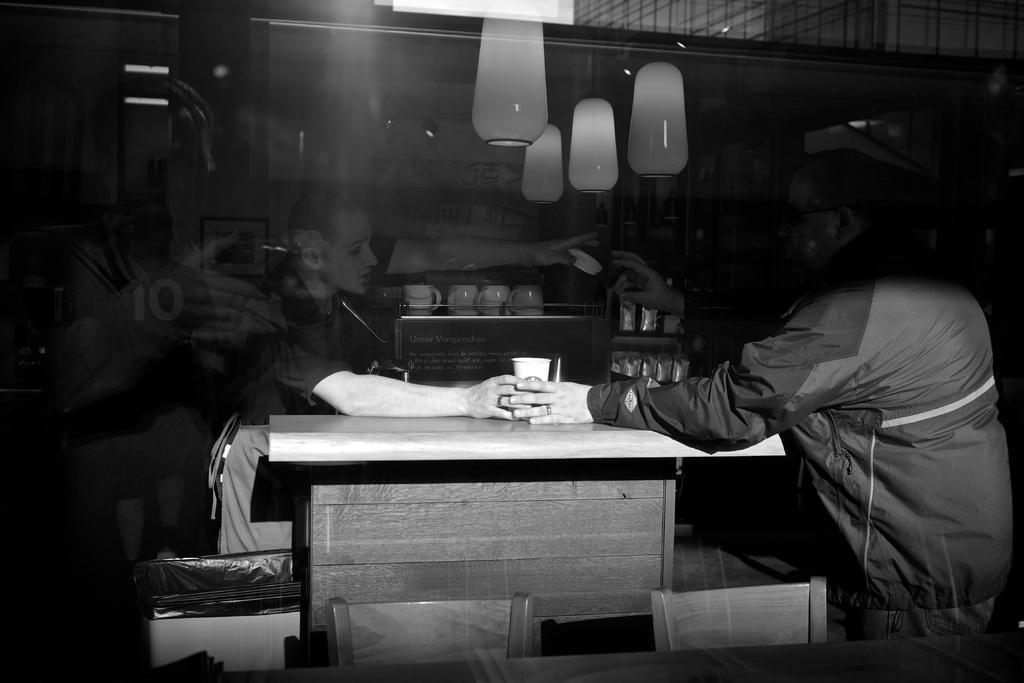How would you summarize this image in a sentence or two? This image is black and white image. There are lights on the top ,there is a table in the middle and two persons are near that table. One is on the right side and other one is on the left side. Both of them are holding a cup. Behind them there is a rack in which there are so many cups. 